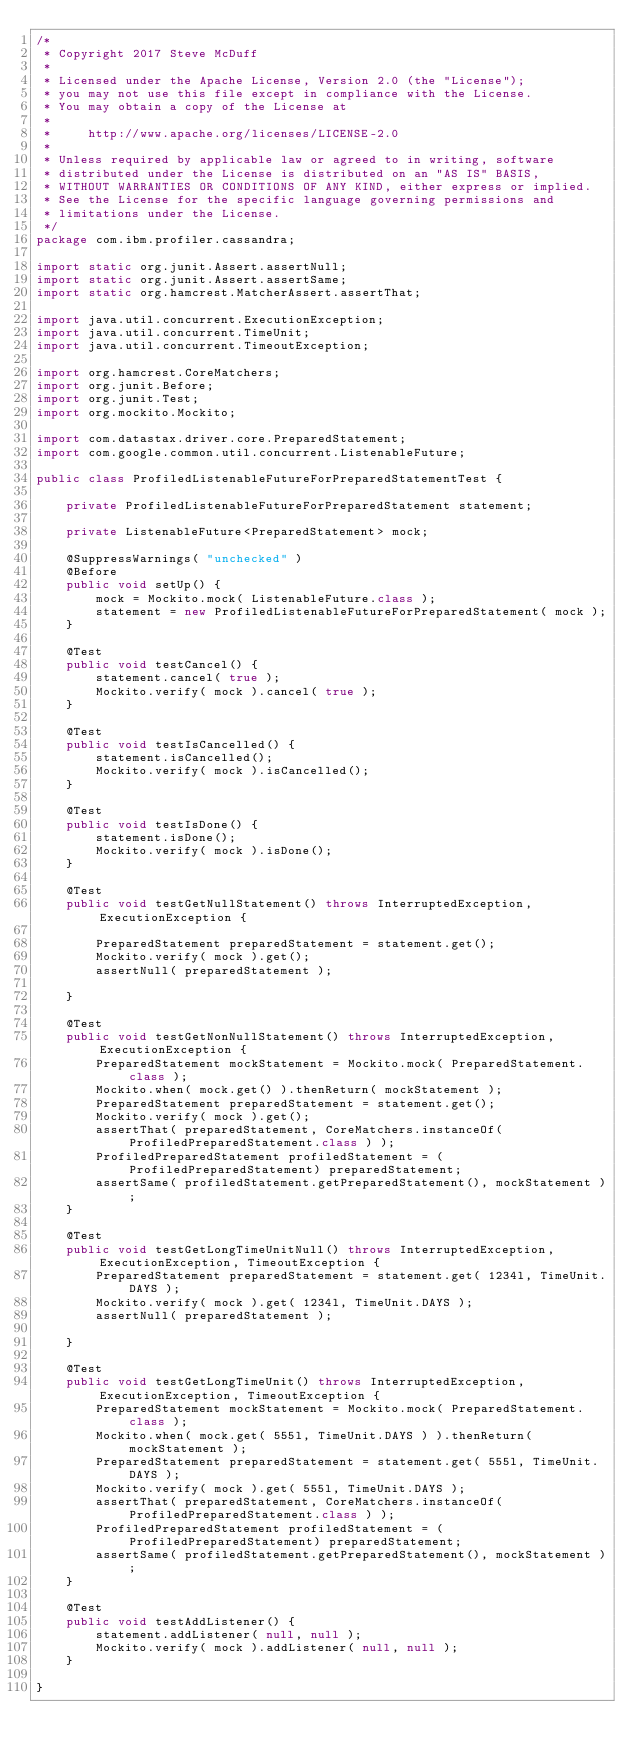Convert code to text. <code><loc_0><loc_0><loc_500><loc_500><_Java_>/*
 * Copyright 2017 Steve McDuff
 * 
 * Licensed under the Apache License, Version 2.0 (the "License");
 * you may not use this file except in compliance with the License.
 * You may obtain a copy of the License at
 * 
 *     http://www.apache.org/licenses/LICENSE-2.0
 * 
 * Unless required by applicable law or agreed to in writing, software
 * distributed under the License is distributed on an "AS IS" BASIS,
 * WITHOUT WARRANTIES OR CONDITIONS OF ANY KIND, either express or implied.
 * See the License for the specific language governing permissions and
 * limitations under the License.
 */
package com.ibm.profiler.cassandra;

import static org.junit.Assert.assertNull;
import static org.junit.Assert.assertSame;
import static org.hamcrest.MatcherAssert.assertThat;

import java.util.concurrent.ExecutionException;
import java.util.concurrent.TimeUnit;
import java.util.concurrent.TimeoutException;

import org.hamcrest.CoreMatchers;
import org.junit.Before;
import org.junit.Test;
import org.mockito.Mockito;

import com.datastax.driver.core.PreparedStatement;
import com.google.common.util.concurrent.ListenableFuture;

public class ProfiledListenableFutureForPreparedStatementTest {

    private ProfiledListenableFutureForPreparedStatement statement;

    private ListenableFuture<PreparedStatement> mock;

    @SuppressWarnings( "unchecked" )
    @Before
    public void setUp() {
        mock = Mockito.mock( ListenableFuture.class );
        statement = new ProfiledListenableFutureForPreparedStatement( mock );
    }

    @Test
    public void testCancel() {
        statement.cancel( true );
        Mockito.verify( mock ).cancel( true );
    }

    @Test
    public void testIsCancelled() {
        statement.isCancelled();
        Mockito.verify( mock ).isCancelled();
    }

    @Test
    public void testIsDone() {
        statement.isDone();
        Mockito.verify( mock ).isDone();
    }

    @Test
    public void testGetNullStatement() throws InterruptedException, ExecutionException {

        PreparedStatement preparedStatement = statement.get();
        Mockito.verify( mock ).get();
        assertNull( preparedStatement );

    }

    @Test
    public void testGetNonNullStatement() throws InterruptedException, ExecutionException {
        PreparedStatement mockStatement = Mockito.mock( PreparedStatement.class );
        Mockito.when( mock.get() ).thenReturn( mockStatement );
        PreparedStatement preparedStatement = statement.get();
        Mockito.verify( mock ).get();
        assertThat( preparedStatement, CoreMatchers.instanceOf( ProfiledPreparedStatement.class ) );
        ProfiledPreparedStatement profiledStatement = (ProfiledPreparedStatement) preparedStatement;
        assertSame( profiledStatement.getPreparedStatement(), mockStatement );
    }

    @Test
    public void testGetLongTimeUnitNull() throws InterruptedException, ExecutionException, TimeoutException {
        PreparedStatement preparedStatement = statement.get( 1234l, TimeUnit.DAYS );
        Mockito.verify( mock ).get( 1234l, TimeUnit.DAYS );
        assertNull( preparedStatement );

    }

    @Test
    public void testGetLongTimeUnit() throws InterruptedException, ExecutionException, TimeoutException {
        PreparedStatement mockStatement = Mockito.mock( PreparedStatement.class );
        Mockito.when( mock.get( 555l, TimeUnit.DAYS ) ).thenReturn( mockStatement );
        PreparedStatement preparedStatement = statement.get( 555l, TimeUnit.DAYS );
        Mockito.verify( mock ).get( 555l, TimeUnit.DAYS );
        assertThat( preparedStatement, CoreMatchers.instanceOf( ProfiledPreparedStatement.class ) );
        ProfiledPreparedStatement profiledStatement = (ProfiledPreparedStatement) preparedStatement;
        assertSame( profiledStatement.getPreparedStatement(), mockStatement );
    }

    @Test
    public void testAddListener() {
        statement.addListener( null, null );
        Mockito.verify( mock ).addListener( null, null );
    }

}
</code> 